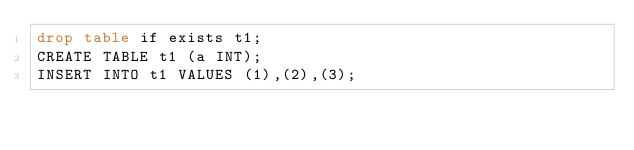<code> <loc_0><loc_0><loc_500><loc_500><_SQL_>drop table if exists t1;
CREATE TABLE t1 (a INT);
INSERT INTO t1 VALUES (1),(2),(3);</code> 